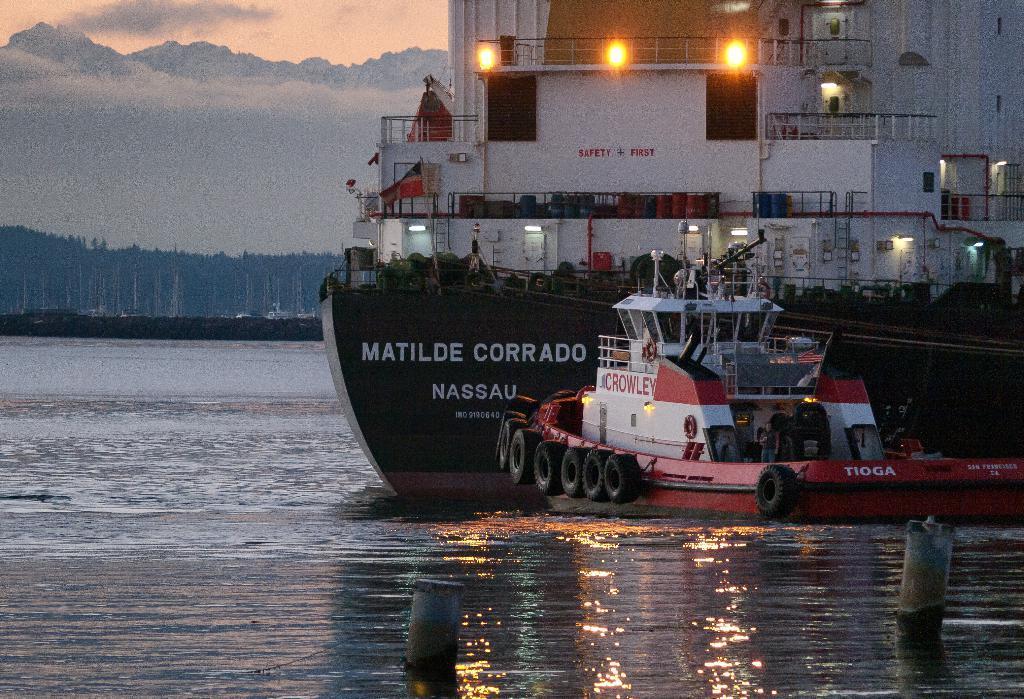Can you describe this image briefly? In the foreground I can see a boat in the water. In the background I can see trees, poles and vehicles on the road. At the top I can see the sky. This image is taken may be near the lake. 